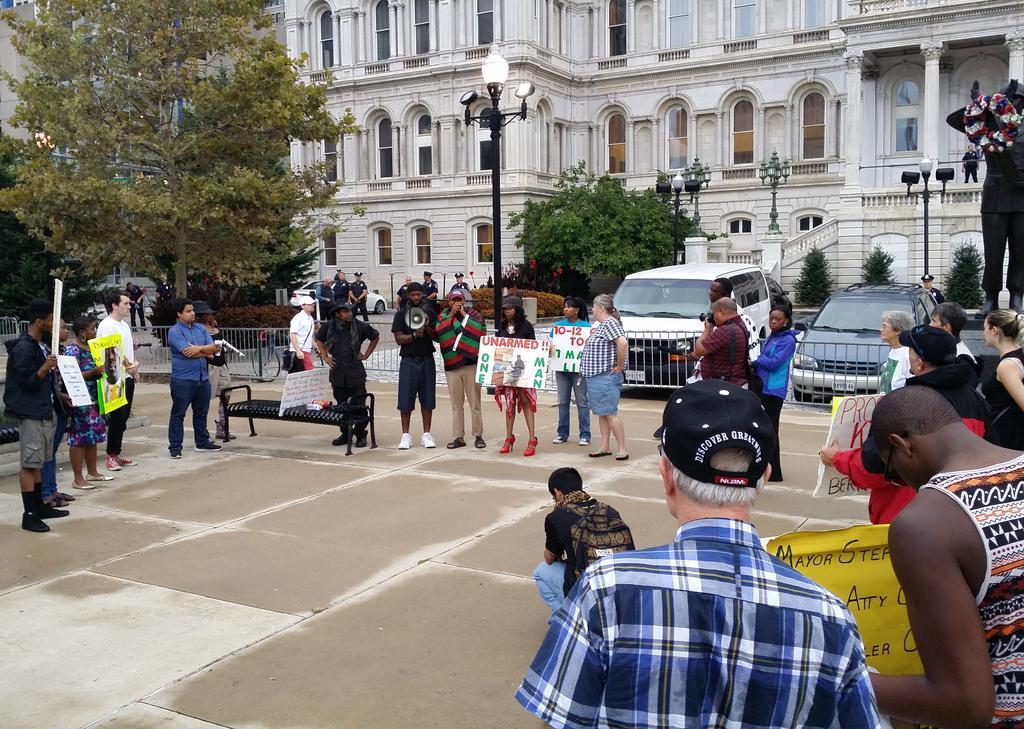Could you give a brief overview of what you see in this image? In this image we can see so many people are standing and holding banners in their hand. One man is holding speaker. Behind them cars, trees, poles, grille and buildings are present. 